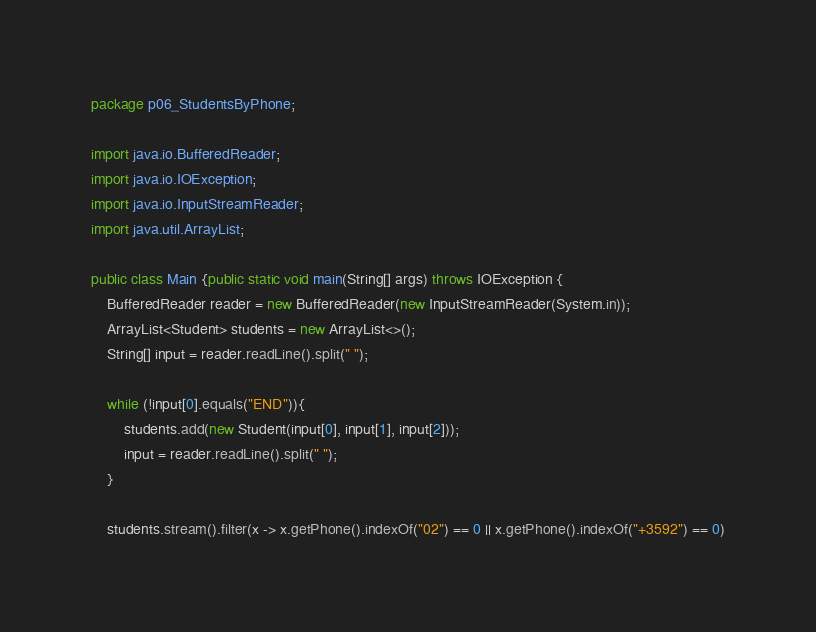<code> <loc_0><loc_0><loc_500><loc_500><_Java_>package p06_StudentsByPhone;

import java.io.BufferedReader;
import java.io.IOException;
import java.io.InputStreamReader;
import java.util.ArrayList;

public class Main {public static void main(String[] args) throws IOException {
    BufferedReader reader = new BufferedReader(new InputStreamReader(System.in));
    ArrayList<Student> students = new ArrayList<>();
    String[] input = reader.readLine().split(" ");

    while (!input[0].equals("END")){
        students.add(new Student(input[0], input[1], input[2]));
        input = reader.readLine().split(" ");
    }

    students.stream().filter(x -> x.getPhone().indexOf("02") == 0 || x.getPhone().indexOf("+3592") == 0)</code> 